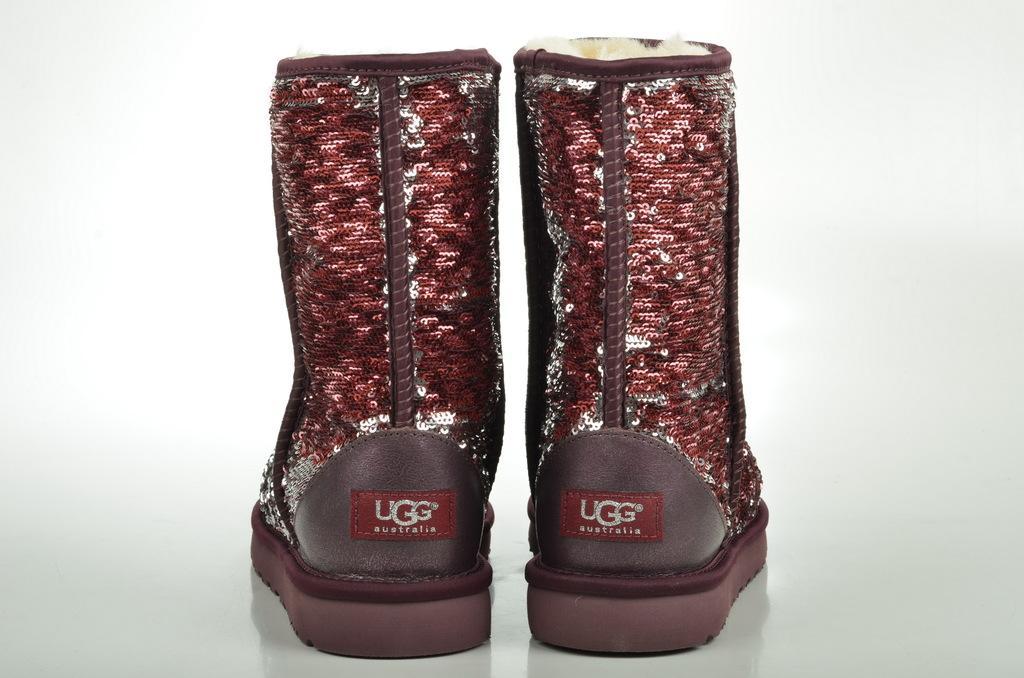Describe this image in one or two sentences. In this image I see 2 boots which are of brown, maroon and white in color and I see few words written on these cloth and it is white in the background and I see the white surface over here. 